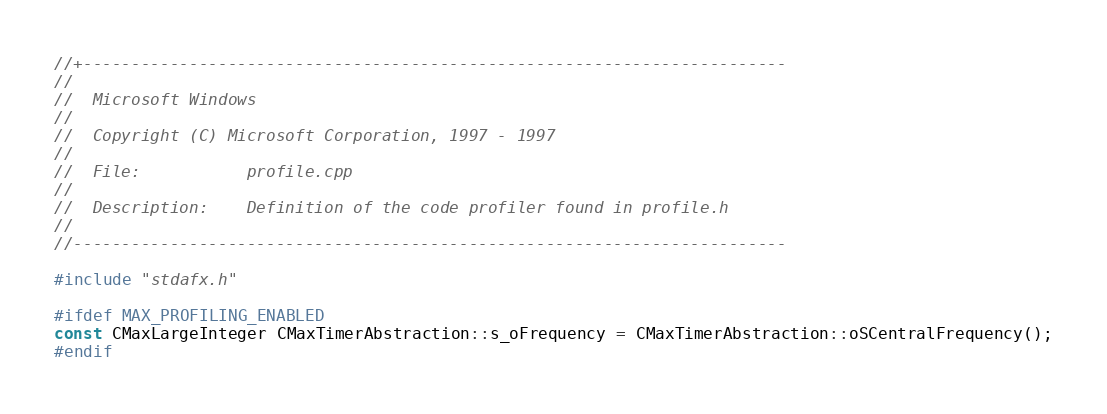<code> <loc_0><loc_0><loc_500><loc_500><_C++_>//+-------------------------------------------------------------------------
//
//  Microsoft Windows
//
//  Copyright (C) Microsoft Corporation, 1997 - 1997
//
//  File:       	profile.cpp
//
//  Description:	Definition of the code profiler found in profile.h
//
//--------------------------------------------------------------------------

#include "stdafx.h"

#ifdef MAX_PROFILING_ENABLED
const CMaxLargeInteger CMaxTimerAbstraction::s_oFrequency = CMaxTimerAbstraction::oSCentralFrequency();
#endif</code> 